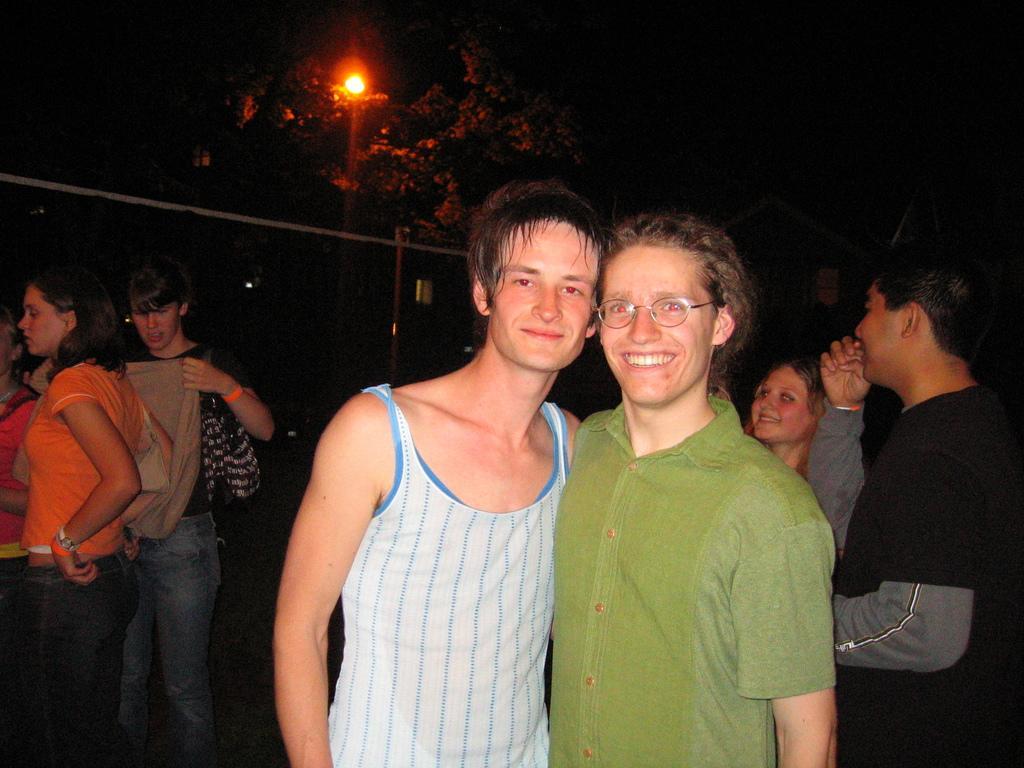Please provide a concise description of this image. In this image we can see two men are standing. In the background the image is dark but we can see few persons, light, trees, pole, wire and houses. 